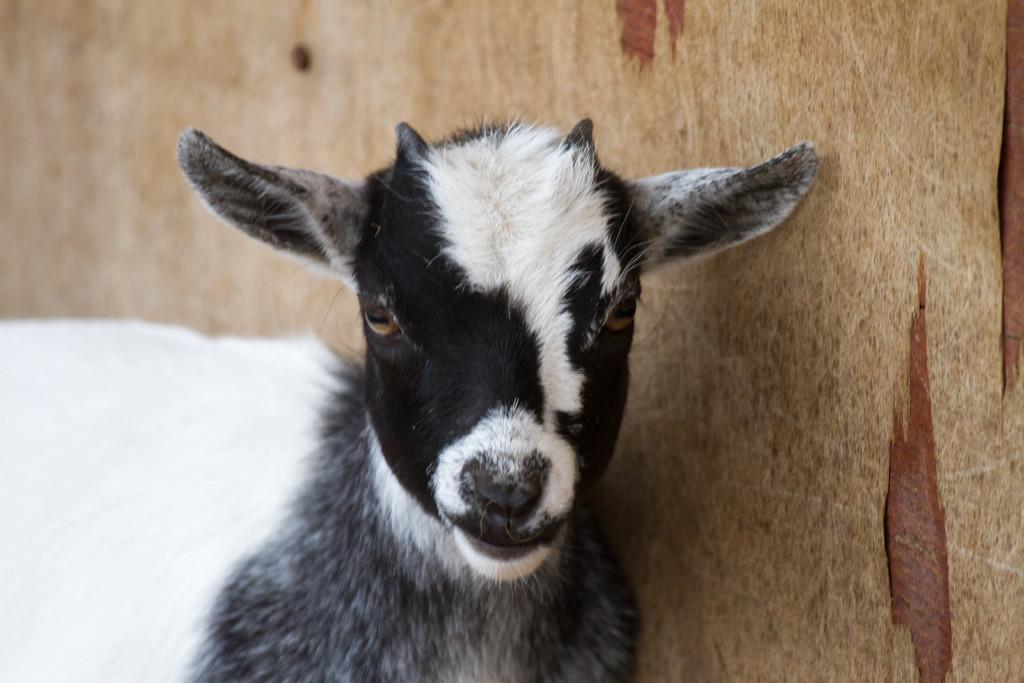What is the main subject in the center of the image? There is a goat in the center of the image. What type of bead is hanging from the goat's neck in the image? There is no bead present in the image; it only features a goat. 